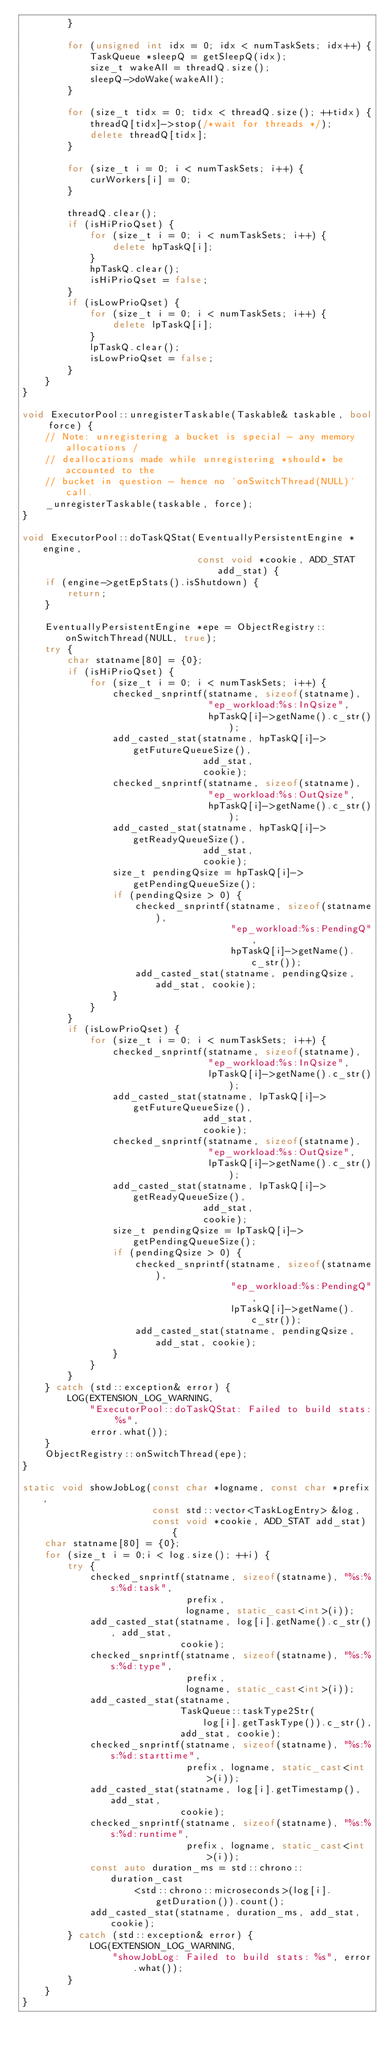<code> <loc_0><loc_0><loc_500><loc_500><_C++_>        }

        for (unsigned int idx = 0; idx < numTaskSets; idx++) {
            TaskQueue *sleepQ = getSleepQ(idx);
            size_t wakeAll = threadQ.size();
            sleepQ->doWake(wakeAll);
        }

        for (size_t tidx = 0; tidx < threadQ.size(); ++tidx) {
            threadQ[tidx]->stop(/*wait for threads */);
            delete threadQ[tidx];
        }

        for (size_t i = 0; i < numTaskSets; i++) {
            curWorkers[i] = 0;
        }

        threadQ.clear();
        if (isHiPrioQset) {
            for (size_t i = 0; i < numTaskSets; i++) {
                delete hpTaskQ[i];
            }
            hpTaskQ.clear();
            isHiPrioQset = false;
        }
        if (isLowPrioQset) {
            for (size_t i = 0; i < numTaskSets; i++) {
                delete lpTaskQ[i];
            }
            lpTaskQ.clear();
            isLowPrioQset = false;
        }
    }
}

void ExecutorPool::unregisterTaskable(Taskable& taskable, bool force) {
    // Note: unregistering a bucket is special - any memory allocations /
    // deallocations made while unregistering *should* be accounted to the
    // bucket in question - hence no `onSwitchThread(NULL)` call.
    _unregisterTaskable(taskable, force);
}

void ExecutorPool::doTaskQStat(EventuallyPersistentEngine *engine,
                               const void *cookie, ADD_STAT add_stat) {
    if (engine->getEpStats().isShutdown) {
        return;
    }

    EventuallyPersistentEngine *epe = ObjectRegistry::onSwitchThread(NULL, true);
    try {
        char statname[80] = {0};
        if (isHiPrioQset) {
            for (size_t i = 0; i < numTaskSets; i++) {
                checked_snprintf(statname, sizeof(statname),
                                 "ep_workload:%s:InQsize",
                                 hpTaskQ[i]->getName().c_str());
                add_casted_stat(statname, hpTaskQ[i]->getFutureQueueSize(),
                                add_stat,
                                cookie);
                checked_snprintf(statname, sizeof(statname),
                                 "ep_workload:%s:OutQsize",
                                 hpTaskQ[i]->getName().c_str());
                add_casted_stat(statname, hpTaskQ[i]->getReadyQueueSize(),
                                add_stat,
                                cookie);
                size_t pendingQsize = hpTaskQ[i]->getPendingQueueSize();
                if (pendingQsize > 0) {
                    checked_snprintf(statname, sizeof(statname),
                                     "ep_workload:%s:PendingQ",
                                     hpTaskQ[i]->getName().c_str());
                    add_casted_stat(statname, pendingQsize, add_stat, cookie);
                }
            }
        }
        if (isLowPrioQset) {
            for (size_t i = 0; i < numTaskSets; i++) {
                checked_snprintf(statname, sizeof(statname),
                                 "ep_workload:%s:InQsize",
                                 lpTaskQ[i]->getName().c_str());
                add_casted_stat(statname, lpTaskQ[i]->getFutureQueueSize(),
                                add_stat,
                                cookie);
                checked_snprintf(statname, sizeof(statname),
                                 "ep_workload:%s:OutQsize",
                                 lpTaskQ[i]->getName().c_str());
                add_casted_stat(statname, lpTaskQ[i]->getReadyQueueSize(),
                                add_stat,
                                cookie);
                size_t pendingQsize = lpTaskQ[i]->getPendingQueueSize();
                if (pendingQsize > 0) {
                    checked_snprintf(statname, sizeof(statname),
                                     "ep_workload:%s:PendingQ",
                                     lpTaskQ[i]->getName().c_str());
                    add_casted_stat(statname, pendingQsize, add_stat, cookie);
                }
            }
        }
    } catch (std::exception& error) {
        LOG(EXTENSION_LOG_WARNING,
            "ExecutorPool::doTaskQStat: Failed to build stats: %s",
            error.what());
    }
    ObjectRegistry::onSwitchThread(epe);
}

static void showJobLog(const char *logname, const char *prefix,
                       const std::vector<TaskLogEntry> &log,
                       const void *cookie, ADD_STAT add_stat) {
    char statname[80] = {0};
    for (size_t i = 0;i < log.size(); ++i) {
        try {
            checked_snprintf(statname, sizeof(statname), "%s:%s:%d:task",
                             prefix,
                             logname, static_cast<int>(i));
            add_casted_stat(statname, log[i].getName().c_str(), add_stat,
                            cookie);
            checked_snprintf(statname, sizeof(statname), "%s:%s:%d:type",
                             prefix,
                             logname, static_cast<int>(i));
            add_casted_stat(statname,
                            TaskQueue::taskType2Str(
                                log[i].getTaskType()).c_str(),
                            add_stat, cookie);
            checked_snprintf(statname, sizeof(statname), "%s:%s:%d:starttime",
                             prefix, logname, static_cast<int>(i));
            add_casted_stat(statname, log[i].getTimestamp(), add_stat,
                            cookie);
            checked_snprintf(statname, sizeof(statname), "%s:%s:%d:runtime",
                             prefix, logname, static_cast<int>(i));
            const auto duration_ms = std::chrono::duration_cast
                    <std::chrono::microseconds>(log[i].getDuration()).count();
            add_casted_stat(statname, duration_ms, add_stat, cookie);
        } catch (std::exception& error) {
            LOG(EXTENSION_LOG_WARNING,
                "showJobLog: Failed to build stats: %s", error.what());
        }
    }
}
</code> 